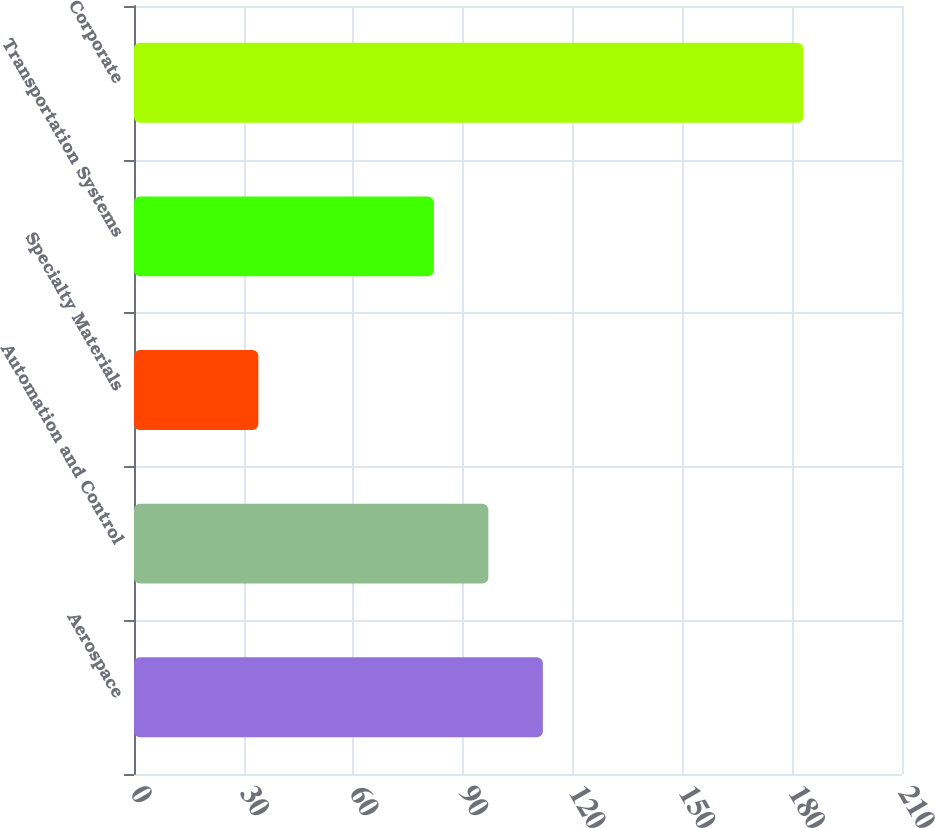Convert chart. <chart><loc_0><loc_0><loc_500><loc_500><bar_chart><fcel>Aerospace<fcel>Automation and Control<fcel>Specialty Materials<fcel>Transportation Systems<fcel>Corporate<nl><fcel>111.8<fcel>96.9<fcel>34<fcel>82<fcel>183<nl></chart> 